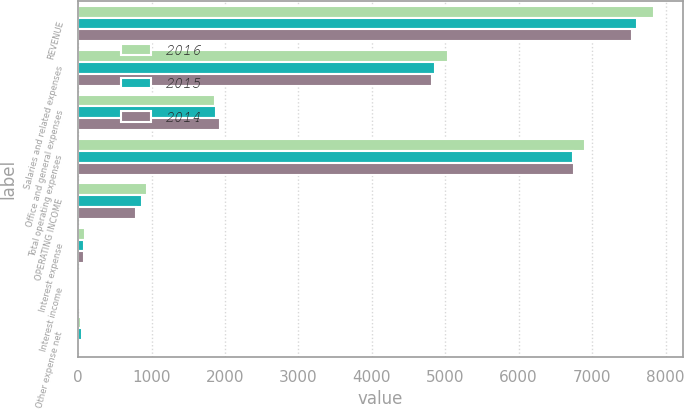Convert chart to OTSL. <chart><loc_0><loc_0><loc_500><loc_500><stacked_bar_chart><ecel><fcel>REVENUE<fcel>Salaries and related expenses<fcel>Office and general expenses<fcel>Total operating expenses<fcel>OPERATING INCOME<fcel>Interest expense<fcel>Interest income<fcel>Other expense net<nl><fcel>2016<fcel>7846.6<fcel>5038.1<fcel>1870.5<fcel>6908.6<fcel>938<fcel>90.6<fcel>20.1<fcel>37.3<nl><fcel>2015<fcel>7613.8<fcel>4857.7<fcel>1884.2<fcel>6741.9<fcel>871.9<fcel>85.8<fcel>22.8<fcel>46.7<nl><fcel>2014<fcel>7537.1<fcel>4820.4<fcel>1928.3<fcel>6748.7<fcel>788.4<fcel>84.9<fcel>27.4<fcel>10.2<nl></chart> 